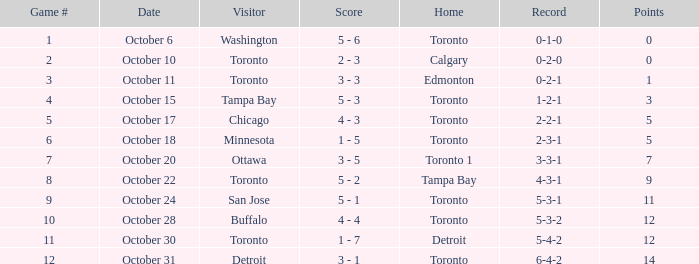What is the tally when the record was 5-4-2? 1 - 7. 